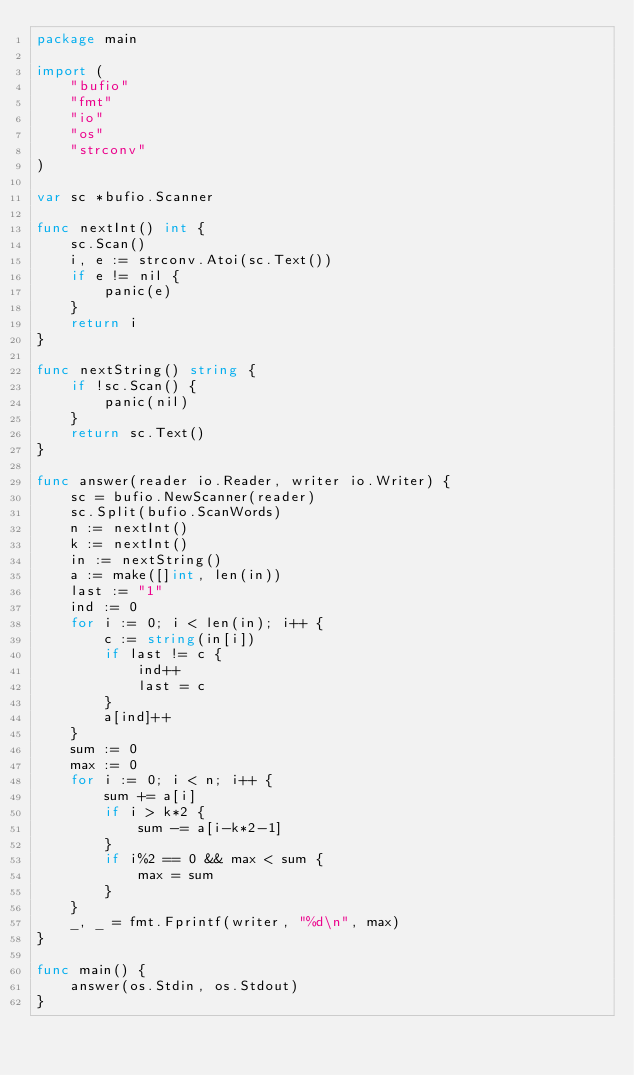Convert code to text. <code><loc_0><loc_0><loc_500><loc_500><_Go_>package main

import (
	"bufio"
	"fmt"
	"io"
	"os"
	"strconv"
)

var sc *bufio.Scanner

func nextInt() int {
	sc.Scan()
	i, e := strconv.Atoi(sc.Text())
	if e != nil {
		panic(e)
	}
	return i
}

func nextString() string {
	if !sc.Scan() {
		panic(nil)
	}
	return sc.Text()
}

func answer(reader io.Reader, writer io.Writer) {
	sc = bufio.NewScanner(reader)
	sc.Split(bufio.ScanWords)
	n := nextInt()
	k := nextInt()
	in := nextString()
	a := make([]int, len(in))
	last := "1"
	ind := 0
	for i := 0; i < len(in); i++ {
		c := string(in[i])
		if last != c {
			ind++
			last = c
		}
		a[ind]++
	}
	sum := 0
	max := 0
	for i := 0; i < n; i++ {
		sum += a[i]
		if i > k*2 {
			sum -= a[i-k*2-1]
		}
		if i%2 == 0 && max < sum {
			max = sum
		}
	}
	_, _ = fmt.Fprintf(writer, "%d\n", max)
}

func main() {
	answer(os.Stdin, os.Stdout)
}
</code> 